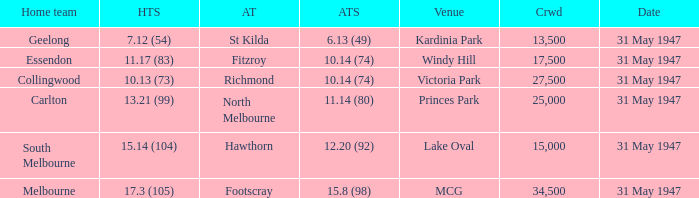What is the listed crowd when hawthorn is away? 1.0. 